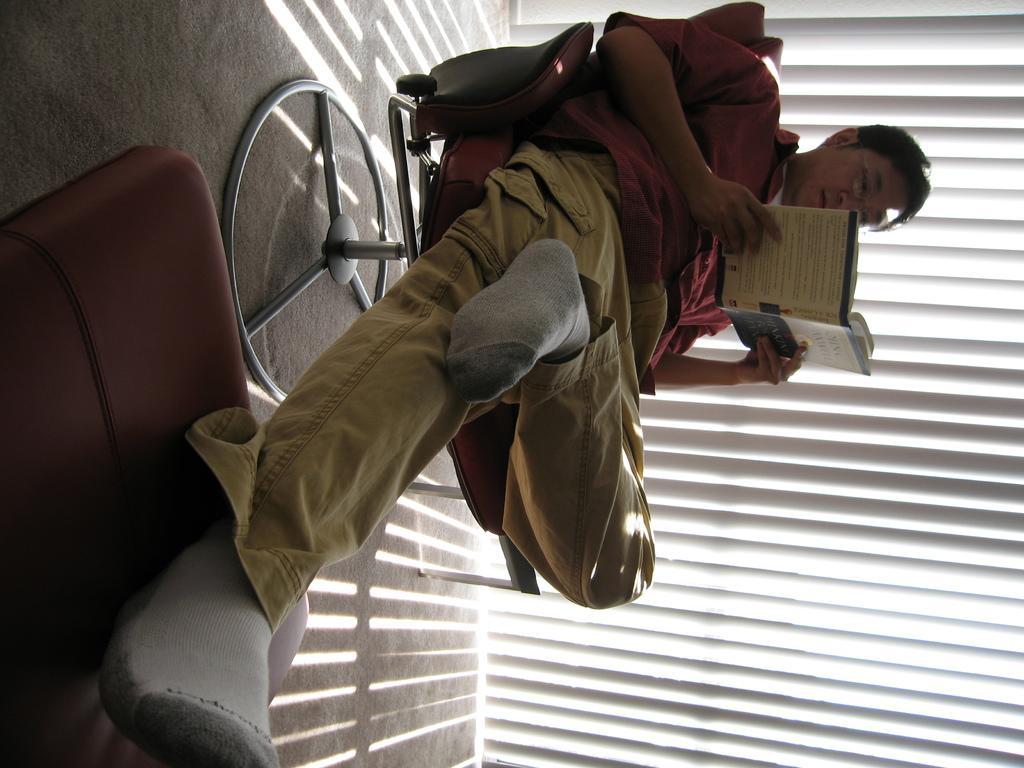Describe this image in one or two sentences. In this image I can see a man is sitting on a chair and I can see he is holding a book. I can also see he is wearing red shirt and pant. In the background I can see window blind and on floor I can see shadows. 